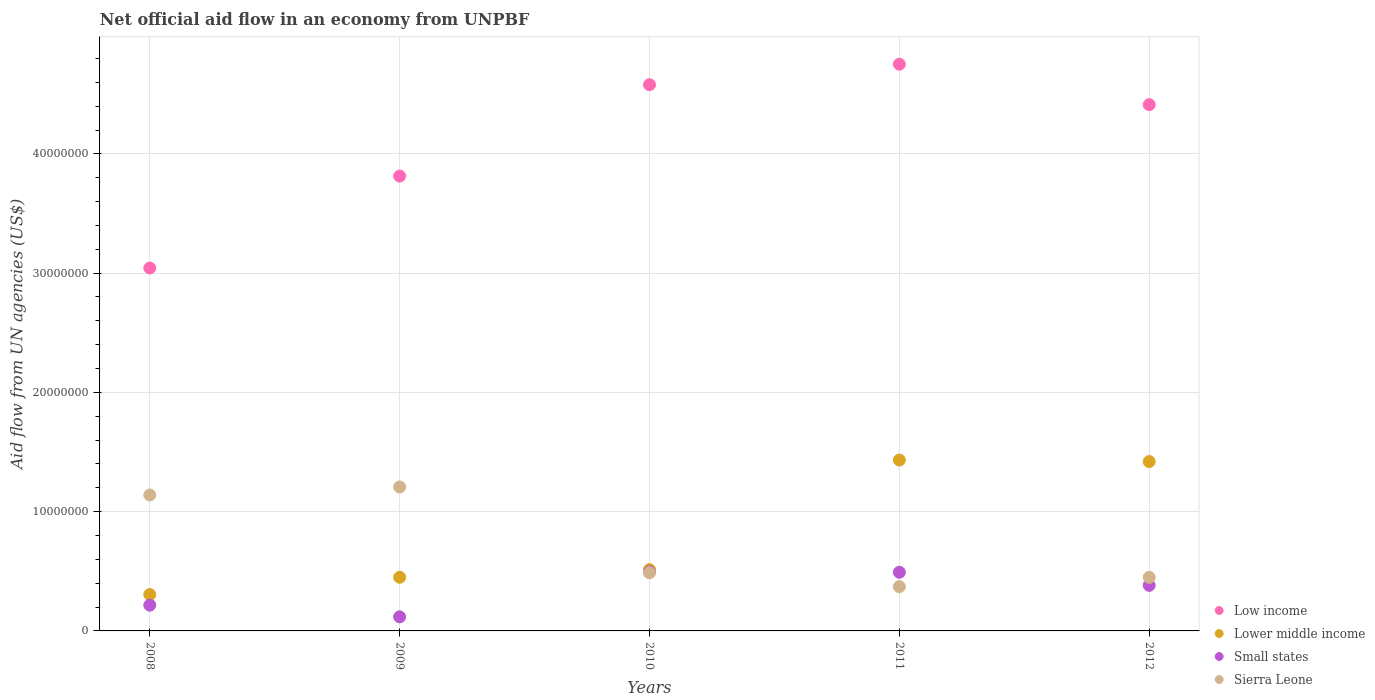How many different coloured dotlines are there?
Offer a terse response. 4. Is the number of dotlines equal to the number of legend labels?
Provide a short and direct response. Yes. What is the net official aid flow in Small states in 2010?
Provide a succinct answer. 4.95e+06. Across all years, what is the maximum net official aid flow in Lower middle income?
Keep it short and to the point. 1.43e+07. Across all years, what is the minimum net official aid flow in Low income?
Your answer should be compact. 3.04e+07. In which year was the net official aid flow in Low income minimum?
Provide a succinct answer. 2008. What is the total net official aid flow in Small states in the graph?
Your answer should be very brief. 1.70e+07. What is the difference between the net official aid flow in Lower middle income in 2010 and that in 2011?
Make the answer very short. -9.19e+06. What is the difference between the net official aid flow in Low income in 2009 and the net official aid flow in Sierra Leone in 2008?
Offer a terse response. 2.67e+07. What is the average net official aid flow in Small states per year?
Your answer should be compact. 3.41e+06. In the year 2009, what is the difference between the net official aid flow in Lower middle income and net official aid flow in Low income?
Your answer should be very brief. -3.36e+07. In how many years, is the net official aid flow in Lower middle income greater than 28000000 US$?
Ensure brevity in your answer.  0. What is the ratio of the net official aid flow in Lower middle income in 2009 to that in 2010?
Make the answer very short. 0.88. Is the difference between the net official aid flow in Lower middle income in 2008 and 2010 greater than the difference between the net official aid flow in Low income in 2008 and 2010?
Offer a very short reply. Yes. What is the difference between the highest and the second highest net official aid flow in Sierra Leone?
Make the answer very short. 6.70e+05. What is the difference between the highest and the lowest net official aid flow in Lower middle income?
Provide a short and direct response. 1.13e+07. In how many years, is the net official aid flow in Small states greater than the average net official aid flow in Small states taken over all years?
Ensure brevity in your answer.  3. Is the sum of the net official aid flow in Low income in 2008 and 2009 greater than the maximum net official aid flow in Small states across all years?
Make the answer very short. Yes. Is it the case that in every year, the sum of the net official aid flow in Small states and net official aid flow in Low income  is greater than the net official aid flow in Sierra Leone?
Give a very brief answer. Yes. What is the difference between two consecutive major ticks on the Y-axis?
Make the answer very short. 1.00e+07. Does the graph contain any zero values?
Make the answer very short. No. Does the graph contain grids?
Provide a short and direct response. Yes. How many legend labels are there?
Ensure brevity in your answer.  4. How are the legend labels stacked?
Offer a terse response. Vertical. What is the title of the graph?
Keep it short and to the point. Net official aid flow in an economy from UNPBF. What is the label or title of the X-axis?
Give a very brief answer. Years. What is the label or title of the Y-axis?
Your response must be concise. Aid flow from UN agencies (US$). What is the Aid flow from UN agencies (US$) of Low income in 2008?
Your answer should be very brief. 3.04e+07. What is the Aid flow from UN agencies (US$) of Lower middle income in 2008?
Provide a succinct answer. 3.05e+06. What is the Aid flow from UN agencies (US$) in Small states in 2008?
Keep it short and to the point. 2.16e+06. What is the Aid flow from UN agencies (US$) in Sierra Leone in 2008?
Keep it short and to the point. 1.14e+07. What is the Aid flow from UN agencies (US$) of Low income in 2009?
Give a very brief answer. 3.81e+07. What is the Aid flow from UN agencies (US$) in Lower middle income in 2009?
Provide a succinct answer. 4.50e+06. What is the Aid flow from UN agencies (US$) of Small states in 2009?
Your answer should be very brief. 1.18e+06. What is the Aid flow from UN agencies (US$) in Sierra Leone in 2009?
Offer a terse response. 1.21e+07. What is the Aid flow from UN agencies (US$) in Low income in 2010?
Your response must be concise. 4.58e+07. What is the Aid flow from UN agencies (US$) in Lower middle income in 2010?
Offer a terse response. 5.14e+06. What is the Aid flow from UN agencies (US$) of Small states in 2010?
Give a very brief answer. 4.95e+06. What is the Aid flow from UN agencies (US$) of Sierra Leone in 2010?
Give a very brief answer. 4.88e+06. What is the Aid flow from UN agencies (US$) of Low income in 2011?
Your answer should be compact. 4.75e+07. What is the Aid flow from UN agencies (US$) in Lower middle income in 2011?
Offer a terse response. 1.43e+07. What is the Aid flow from UN agencies (US$) in Small states in 2011?
Provide a succinct answer. 4.92e+06. What is the Aid flow from UN agencies (US$) of Sierra Leone in 2011?
Provide a succinct answer. 3.71e+06. What is the Aid flow from UN agencies (US$) in Low income in 2012?
Provide a short and direct response. 4.41e+07. What is the Aid flow from UN agencies (US$) of Lower middle income in 2012?
Provide a short and direct response. 1.42e+07. What is the Aid flow from UN agencies (US$) of Small states in 2012?
Keep it short and to the point. 3.82e+06. What is the Aid flow from UN agencies (US$) of Sierra Leone in 2012?
Give a very brief answer. 4.49e+06. Across all years, what is the maximum Aid flow from UN agencies (US$) of Low income?
Offer a terse response. 4.75e+07. Across all years, what is the maximum Aid flow from UN agencies (US$) of Lower middle income?
Make the answer very short. 1.43e+07. Across all years, what is the maximum Aid flow from UN agencies (US$) of Small states?
Offer a terse response. 4.95e+06. Across all years, what is the maximum Aid flow from UN agencies (US$) in Sierra Leone?
Give a very brief answer. 1.21e+07. Across all years, what is the minimum Aid flow from UN agencies (US$) in Low income?
Your answer should be very brief. 3.04e+07. Across all years, what is the minimum Aid flow from UN agencies (US$) of Lower middle income?
Offer a terse response. 3.05e+06. Across all years, what is the minimum Aid flow from UN agencies (US$) in Small states?
Offer a terse response. 1.18e+06. Across all years, what is the minimum Aid flow from UN agencies (US$) of Sierra Leone?
Your answer should be very brief. 3.71e+06. What is the total Aid flow from UN agencies (US$) in Low income in the graph?
Make the answer very short. 2.06e+08. What is the total Aid flow from UN agencies (US$) of Lower middle income in the graph?
Offer a very short reply. 4.12e+07. What is the total Aid flow from UN agencies (US$) in Small states in the graph?
Provide a succinct answer. 1.70e+07. What is the total Aid flow from UN agencies (US$) in Sierra Leone in the graph?
Your answer should be very brief. 3.66e+07. What is the difference between the Aid flow from UN agencies (US$) in Low income in 2008 and that in 2009?
Ensure brevity in your answer.  -7.71e+06. What is the difference between the Aid flow from UN agencies (US$) of Lower middle income in 2008 and that in 2009?
Ensure brevity in your answer.  -1.45e+06. What is the difference between the Aid flow from UN agencies (US$) of Small states in 2008 and that in 2009?
Keep it short and to the point. 9.80e+05. What is the difference between the Aid flow from UN agencies (US$) of Sierra Leone in 2008 and that in 2009?
Provide a succinct answer. -6.70e+05. What is the difference between the Aid flow from UN agencies (US$) in Low income in 2008 and that in 2010?
Offer a very short reply. -1.54e+07. What is the difference between the Aid flow from UN agencies (US$) in Lower middle income in 2008 and that in 2010?
Your answer should be very brief. -2.09e+06. What is the difference between the Aid flow from UN agencies (US$) of Small states in 2008 and that in 2010?
Offer a terse response. -2.79e+06. What is the difference between the Aid flow from UN agencies (US$) in Sierra Leone in 2008 and that in 2010?
Keep it short and to the point. 6.52e+06. What is the difference between the Aid flow from UN agencies (US$) in Low income in 2008 and that in 2011?
Give a very brief answer. -1.71e+07. What is the difference between the Aid flow from UN agencies (US$) of Lower middle income in 2008 and that in 2011?
Keep it short and to the point. -1.13e+07. What is the difference between the Aid flow from UN agencies (US$) of Small states in 2008 and that in 2011?
Offer a very short reply. -2.76e+06. What is the difference between the Aid flow from UN agencies (US$) of Sierra Leone in 2008 and that in 2011?
Ensure brevity in your answer.  7.69e+06. What is the difference between the Aid flow from UN agencies (US$) of Low income in 2008 and that in 2012?
Make the answer very short. -1.37e+07. What is the difference between the Aid flow from UN agencies (US$) of Lower middle income in 2008 and that in 2012?
Offer a very short reply. -1.12e+07. What is the difference between the Aid flow from UN agencies (US$) of Small states in 2008 and that in 2012?
Your response must be concise. -1.66e+06. What is the difference between the Aid flow from UN agencies (US$) of Sierra Leone in 2008 and that in 2012?
Offer a very short reply. 6.91e+06. What is the difference between the Aid flow from UN agencies (US$) in Low income in 2009 and that in 2010?
Offer a terse response. -7.66e+06. What is the difference between the Aid flow from UN agencies (US$) in Lower middle income in 2009 and that in 2010?
Provide a succinct answer. -6.40e+05. What is the difference between the Aid flow from UN agencies (US$) in Small states in 2009 and that in 2010?
Ensure brevity in your answer.  -3.77e+06. What is the difference between the Aid flow from UN agencies (US$) in Sierra Leone in 2009 and that in 2010?
Ensure brevity in your answer.  7.19e+06. What is the difference between the Aid flow from UN agencies (US$) in Low income in 2009 and that in 2011?
Offer a terse response. -9.38e+06. What is the difference between the Aid flow from UN agencies (US$) in Lower middle income in 2009 and that in 2011?
Give a very brief answer. -9.83e+06. What is the difference between the Aid flow from UN agencies (US$) of Small states in 2009 and that in 2011?
Offer a terse response. -3.74e+06. What is the difference between the Aid flow from UN agencies (US$) in Sierra Leone in 2009 and that in 2011?
Offer a terse response. 8.36e+06. What is the difference between the Aid flow from UN agencies (US$) in Low income in 2009 and that in 2012?
Provide a short and direct response. -5.99e+06. What is the difference between the Aid flow from UN agencies (US$) of Lower middle income in 2009 and that in 2012?
Your answer should be very brief. -9.70e+06. What is the difference between the Aid flow from UN agencies (US$) in Small states in 2009 and that in 2012?
Offer a terse response. -2.64e+06. What is the difference between the Aid flow from UN agencies (US$) of Sierra Leone in 2009 and that in 2012?
Provide a short and direct response. 7.58e+06. What is the difference between the Aid flow from UN agencies (US$) in Low income in 2010 and that in 2011?
Ensure brevity in your answer.  -1.72e+06. What is the difference between the Aid flow from UN agencies (US$) in Lower middle income in 2010 and that in 2011?
Provide a succinct answer. -9.19e+06. What is the difference between the Aid flow from UN agencies (US$) in Sierra Leone in 2010 and that in 2011?
Your answer should be compact. 1.17e+06. What is the difference between the Aid flow from UN agencies (US$) of Low income in 2010 and that in 2012?
Your answer should be compact. 1.67e+06. What is the difference between the Aid flow from UN agencies (US$) of Lower middle income in 2010 and that in 2012?
Keep it short and to the point. -9.06e+06. What is the difference between the Aid flow from UN agencies (US$) of Small states in 2010 and that in 2012?
Offer a terse response. 1.13e+06. What is the difference between the Aid flow from UN agencies (US$) in Sierra Leone in 2010 and that in 2012?
Give a very brief answer. 3.90e+05. What is the difference between the Aid flow from UN agencies (US$) in Low income in 2011 and that in 2012?
Provide a short and direct response. 3.39e+06. What is the difference between the Aid flow from UN agencies (US$) of Small states in 2011 and that in 2012?
Offer a terse response. 1.10e+06. What is the difference between the Aid flow from UN agencies (US$) of Sierra Leone in 2011 and that in 2012?
Provide a succinct answer. -7.80e+05. What is the difference between the Aid flow from UN agencies (US$) of Low income in 2008 and the Aid flow from UN agencies (US$) of Lower middle income in 2009?
Offer a terse response. 2.59e+07. What is the difference between the Aid flow from UN agencies (US$) of Low income in 2008 and the Aid flow from UN agencies (US$) of Small states in 2009?
Ensure brevity in your answer.  2.92e+07. What is the difference between the Aid flow from UN agencies (US$) of Low income in 2008 and the Aid flow from UN agencies (US$) of Sierra Leone in 2009?
Your answer should be compact. 1.84e+07. What is the difference between the Aid flow from UN agencies (US$) in Lower middle income in 2008 and the Aid flow from UN agencies (US$) in Small states in 2009?
Your answer should be very brief. 1.87e+06. What is the difference between the Aid flow from UN agencies (US$) in Lower middle income in 2008 and the Aid flow from UN agencies (US$) in Sierra Leone in 2009?
Your answer should be very brief. -9.02e+06. What is the difference between the Aid flow from UN agencies (US$) of Small states in 2008 and the Aid flow from UN agencies (US$) of Sierra Leone in 2009?
Your response must be concise. -9.91e+06. What is the difference between the Aid flow from UN agencies (US$) in Low income in 2008 and the Aid flow from UN agencies (US$) in Lower middle income in 2010?
Offer a terse response. 2.53e+07. What is the difference between the Aid flow from UN agencies (US$) in Low income in 2008 and the Aid flow from UN agencies (US$) in Small states in 2010?
Provide a succinct answer. 2.55e+07. What is the difference between the Aid flow from UN agencies (US$) in Low income in 2008 and the Aid flow from UN agencies (US$) in Sierra Leone in 2010?
Provide a succinct answer. 2.56e+07. What is the difference between the Aid flow from UN agencies (US$) of Lower middle income in 2008 and the Aid flow from UN agencies (US$) of Small states in 2010?
Provide a succinct answer. -1.90e+06. What is the difference between the Aid flow from UN agencies (US$) of Lower middle income in 2008 and the Aid flow from UN agencies (US$) of Sierra Leone in 2010?
Your answer should be compact. -1.83e+06. What is the difference between the Aid flow from UN agencies (US$) of Small states in 2008 and the Aid flow from UN agencies (US$) of Sierra Leone in 2010?
Your answer should be very brief. -2.72e+06. What is the difference between the Aid flow from UN agencies (US$) in Low income in 2008 and the Aid flow from UN agencies (US$) in Lower middle income in 2011?
Make the answer very short. 1.61e+07. What is the difference between the Aid flow from UN agencies (US$) in Low income in 2008 and the Aid flow from UN agencies (US$) in Small states in 2011?
Provide a succinct answer. 2.55e+07. What is the difference between the Aid flow from UN agencies (US$) of Low income in 2008 and the Aid flow from UN agencies (US$) of Sierra Leone in 2011?
Your answer should be compact. 2.67e+07. What is the difference between the Aid flow from UN agencies (US$) of Lower middle income in 2008 and the Aid flow from UN agencies (US$) of Small states in 2011?
Make the answer very short. -1.87e+06. What is the difference between the Aid flow from UN agencies (US$) of Lower middle income in 2008 and the Aid flow from UN agencies (US$) of Sierra Leone in 2011?
Make the answer very short. -6.60e+05. What is the difference between the Aid flow from UN agencies (US$) of Small states in 2008 and the Aid flow from UN agencies (US$) of Sierra Leone in 2011?
Your answer should be very brief. -1.55e+06. What is the difference between the Aid flow from UN agencies (US$) in Low income in 2008 and the Aid flow from UN agencies (US$) in Lower middle income in 2012?
Your answer should be compact. 1.62e+07. What is the difference between the Aid flow from UN agencies (US$) of Low income in 2008 and the Aid flow from UN agencies (US$) of Small states in 2012?
Offer a very short reply. 2.66e+07. What is the difference between the Aid flow from UN agencies (US$) in Low income in 2008 and the Aid flow from UN agencies (US$) in Sierra Leone in 2012?
Your answer should be very brief. 2.59e+07. What is the difference between the Aid flow from UN agencies (US$) of Lower middle income in 2008 and the Aid flow from UN agencies (US$) of Small states in 2012?
Provide a succinct answer. -7.70e+05. What is the difference between the Aid flow from UN agencies (US$) in Lower middle income in 2008 and the Aid flow from UN agencies (US$) in Sierra Leone in 2012?
Your response must be concise. -1.44e+06. What is the difference between the Aid flow from UN agencies (US$) in Small states in 2008 and the Aid flow from UN agencies (US$) in Sierra Leone in 2012?
Make the answer very short. -2.33e+06. What is the difference between the Aid flow from UN agencies (US$) of Low income in 2009 and the Aid flow from UN agencies (US$) of Lower middle income in 2010?
Provide a short and direct response. 3.30e+07. What is the difference between the Aid flow from UN agencies (US$) in Low income in 2009 and the Aid flow from UN agencies (US$) in Small states in 2010?
Make the answer very short. 3.32e+07. What is the difference between the Aid flow from UN agencies (US$) in Low income in 2009 and the Aid flow from UN agencies (US$) in Sierra Leone in 2010?
Your answer should be very brief. 3.33e+07. What is the difference between the Aid flow from UN agencies (US$) in Lower middle income in 2009 and the Aid flow from UN agencies (US$) in Small states in 2010?
Keep it short and to the point. -4.50e+05. What is the difference between the Aid flow from UN agencies (US$) in Lower middle income in 2009 and the Aid flow from UN agencies (US$) in Sierra Leone in 2010?
Ensure brevity in your answer.  -3.80e+05. What is the difference between the Aid flow from UN agencies (US$) in Small states in 2009 and the Aid flow from UN agencies (US$) in Sierra Leone in 2010?
Provide a succinct answer. -3.70e+06. What is the difference between the Aid flow from UN agencies (US$) of Low income in 2009 and the Aid flow from UN agencies (US$) of Lower middle income in 2011?
Make the answer very short. 2.38e+07. What is the difference between the Aid flow from UN agencies (US$) in Low income in 2009 and the Aid flow from UN agencies (US$) in Small states in 2011?
Your answer should be very brief. 3.32e+07. What is the difference between the Aid flow from UN agencies (US$) in Low income in 2009 and the Aid flow from UN agencies (US$) in Sierra Leone in 2011?
Give a very brief answer. 3.44e+07. What is the difference between the Aid flow from UN agencies (US$) of Lower middle income in 2009 and the Aid flow from UN agencies (US$) of Small states in 2011?
Your response must be concise. -4.20e+05. What is the difference between the Aid flow from UN agencies (US$) in Lower middle income in 2009 and the Aid flow from UN agencies (US$) in Sierra Leone in 2011?
Make the answer very short. 7.90e+05. What is the difference between the Aid flow from UN agencies (US$) in Small states in 2009 and the Aid flow from UN agencies (US$) in Sierra Leone in 2011?
Ensure brevity in your answer.  -2.53e+06. What is the difference between the Aid flow from UN agencies (US$) in Low income in 2009 and the Aid flow from UN agencies (US$) in Lower middle income in 2012?
Your answer should be compact. 2.39e+07. What is the difference between the Aid flow from UN agencies (US$) in Low income in 2009 and the Aid flow from UN agencies (US$) in Small states in 2012?
Keep it short and to the point. 3.43e+07. What is the difference between the Aid flow from UN agencies (US$) of Low income in 2009 and the Aid flow from UN agencies (US$) of Sierra Leone in 2012?
Provide a succinct answer. 3.36e+07. What is the difference between the Aid flow from UN agencies (US$) of Lower middle income in 2009 and the Aid flow from UN agencies (US$) of Small states in 2012?
Provide a succinct answer. 6.80e+05. What is the difference between the Aid flow from UN agencies (US$) of Small states in 2009 and the Aid flow from UN agencies (US$) of Sierra Leone in 2012?
Your answer should be compact. -3.31e+06. What is the difference between the Aid flow from UN agencies (US$) in Low income in 2010 and the Aid flow from UN agencies (US$) in Lower middle income in 2011?
Keep it short and to the point. 3.15e+07. What is the difference between the Aid flow from UN agencies (US$) of Low income in 2010 and the Aid flow from UN agencies (US$) of Small states in 2011?
Your answer should be compact. 4.09e+07. What is the difference between the Aid flow from UN agencies (US$) of Low income in 2010 and the Aid flow from UN agencies (US$) of Sierra Leone in 2011?
Your answer should be compact. 4.21e+07. What is the difference between the Aid flow from UN agencies (US$) in Lower middle income in 2010 and the Aid flow from UN agencies (US$) in Small states in 2011?
Offer a very short reply. 2.20e+05. What is the difference between the Aid flow from UN agencies (US$) in Lower middle income in 2010 and the Aid flow from UN agencies (US$) in Sierra Leone in 2011?
Ensure brevity in your answer.  1.43e+06. What is the difference between the Aid flow from UN agencies (US$) in Small states in 2010 and the Aid flow from UN agencies (US$) in Sierra Leone in 2011?
Ensure brevity in your answer.  1.24e+06. What is the difference between the Aid flow from UN agencies (US$) in Low income in 2010 and the Aid flow from UN agencies (US$) in Lower middle income in 2012?
Offer a very short reply. 3.16e+07. What is the difference between the Aid flow from UN agencies (US$) in Low income in 2010 and the Aid flow from UN agencies (US$) in Small states in 2012?
Your response must be concise. 4.20e+07. What is the difference between the Aid flow from UN agencies (US$) in Low income in 2010 and the Aid flow from UN agencies (US$) in Sierra Leone in 2012?
Give a very brief answer. 4.13e+07. What is the difference between the Aid flow from UN agencies (US$) of Lower middle income in 2010 and the Aid flow from UN agencies (US$) of Small states in 2012?
Ensure brevity in your answer.  1.32e+06. What is the difference between the Aid flow from UN agencies (US$) of Lower middle income in 2010 and the Aid flow from UN agencies (US$) of Sierra Leone in 2012?
Provide a succinct answer. 6.50e+05. What is the difference between the Aid flow from UN agencies (US$) in Small states in 2010 and the Aid flow from UN agencies (US$) in Sierra Leone in 2012?
Provide a succinct answer. 4.60e+05. What is the difference between the Aid flow from UN agencies (US$) in Low income in 2011 and the Aid flow from UN agencies (US$) in Lower middle income in 2012?
Keep it short and to the point. 3.33e+07. What is the difference between the Aid flow from UN agencies (US$) in Low income in 2011 and the Aid flow from UN agencies (US$) in Small states in 2012?
Your answer should be compact. 4.37e+07. What is the difference between the Aid flow from UN agencies (US$) of Low income in 2011 and the Aid flow from UN agencies (US$) of Sierra Leone in 2012?
Your answer should be compact. 4.30e+07. What is the difference between the Aid flow from UN agencies (US$) in Lower middle income in 2011 and the Aid flow from UN agencies (US$) in Small states in 2012?
Ensure brevity in your answer.  1.05e+07. What is the difference between the Aid flow from UN agencies (US$) of Lower middle income in 2011 and the Aid flow from UN agencies (US$) of Sierra Leone in 2012?
Keep it short and to the point. 9.84e+06. What is the difference between the Aid flow from UN agencies (US$) of Small states in 2011 and the Aid flow from UN agencies (US$) of Sierra Leone in 2012?
Keep it short and to the point. 4.30e+05. What is the average Aid flow from UN agencies (US$) of Low income per year?
Your answer should be compact. 4.12e+07. What is the average Aid flow from UN agencies (US$) in Lower middle income per year?
Your answer should be compact. 8.24e+06. What is the average Aid flow from UN agencies (US$) of Small states per year?
Keep it short and to the point. 3.41e+06. What is the average Aid flow from UN agencies (US$) in Sierra Leone per year?
Ensure brevity in your answer.  7.31e+06. In the year 2008, what is the difference between the Aid flow from UN agencies (US$) of Low income and Aid flow from UN agencies (US$) of Lower middle income?
Provide a short and direct response. 2.74e+07. In the year 2008, what is the difference between the Aid flow from UN agencies (US$) in Low income and Aid flow from UN agencies (US$) in Small states?
Your answer should be very brief. 2.83e+07. In the year 2008, what is the difference between the Aid flow from UN agencies (US$) in Low income and Aid flow from UN agencies (US$) in Sierra Leone?
Your answer should be compact. 1.90e+07. In the year 2008, what is the difference between the Aid flow from UN agencies (US$) of Lower middle income and Aid flow from UN agencies (US$) of Small states?
Your answer should be compact. 8.90e+05. In the year 2008, what is the difference between the Aid flow from UN agencies (US$) of Lower middle income and Aid flow from UN agencies (US$) of Sierra Leone?
Provide a succinct answer. -8.35e+06. In the year 2008, what is the difference between the Aid flow from UN agencies (US$) in Small states and Aid flow from UN agencies (US$) in Sierra Leone?
Give a very brief answer. -9.24e+06. In the year 2009, what is the difference between the Aid flow from UN agencies (US$) in Low income and Aid flow from UN agencies (US$) in Lower middle income?
Your answer should be compact. 3.36e+07. In the year 2009, what is the difference between the Aid flow from UN agencies (US$) in Low income and Aid flow from UN agencies (US$) in Small states?
Offer a terse response. 3.70e+07. In the year 2009, what is the difference between the Aid flow from UN agencies (US$) of Low income and Aid flow from UN agencies (US$) of Sierra Leone?
Provide a succinct answer. 2.61e+07. In the year 2009, what is the difference between the Aid flow from UN agencies (US$) of Lower middle income and Aid flow from UN agencies (US$) of Small states?
Provide a short and direct response. 3.32e+06. In the year 2009, what is the difference between the Aid flow from UN agencies (US$) in Lower middle income and Aid flow from UN agencies (US$) in Sierra Leone?
Provide a succinct answer. -7.57e+06. In the year 2009, what is the difference between the Aid flow from UN agencies (US$) of Small states and Aid flow from UN agencies (US$) of Sierra Leone?
Ensure brevity in your answer.  -1.09e+07. In the year 2010, what is the difference between the Aid flow from UN agencies (US$) of Low income and Aid flow from UN agencies (US$) of Lower middle income?
Give a very brief answer. 4.07e+07. In the year 2010, what is the difference between the Aid flow from UN agencies (US$) of Low income and Aid flow from UN agencies (US$) of Small states?
Provide a succinct answer. 4.08e+07. In the year 2010, what is the difference between the Aid flow from UN agencies (US$) of Low income and Aid flow from UN agencies (US$) of Sierra Leone?
Offer a very short reply. 4.09e+07. In the year 2010, what is the difference between the Aid flow from UN agencies (US$) of Lower middle income and Aid flow from UN agencies (US$) of Sierra Leone?
Ensure brevity in your answer.  2.60e+05. In the year 2011, what is the difference between the Aid flow from UN agencies (US$) of Low income and Aid flow from UN agencies (US$) of Lower middle income?
Keep it short and to the point. 3.32e+07. In the year 2011, what is the difference between the Aid flow from UN agencies (US$) of Low income and Aid flow from UN agencies (US$) of Small states?
Offer a very short reply. 4.26e+07. In the year 2011, what is the difference between the Aid flow from UN agencies (US$) in Low income and Aid flow from UN agencies (US$) in Sierra Leone?
Offer a very short reply. 4.38e+07. In the year 2011, what is the difference between the Aid flow from UN agencies (US$) in Lower middle income and Aid flow from UN agencies (US$) in Small states?
Ensure brevity in your answer.  9.41e+06. In the year 2011, what is the difference between the Aid flow from UN agencies (US$) in Lower middle income and Aid flow from UN agencies (US$) in Sierra Leone?
Your response must be concise. 1.06e+07. In the year 2011, what is the difference between the Aid flow from UN agencies (US$) in Small states and Aid flow from UN agencies (US$) in Sierra Leone?
Give a very brief answer. 1.21e+06. In the year 2012, what is the difference between the Aid flow from UN agencies (US$) in Low income and Aid flow from UN agencies (US$) in Lower middle income?
Your answer should be very brief. 2.99e+07. In the year 2012, what is the difference between the Aid flow from UN agencies (US$) of Low income and Aid flow from UN agencies (US$) of Small states?
Make the answer very short. 4.03e+07. In the year 2012, what is the difference between the Aid flow from UN agencies (US$) in Low income and Aid flow from UN agencies (US$) in Sierra Leone?
Offer a terse response. 3.96e+07. In the year 2012, what is the difference between the Aid flow from UN agencies (US$) of Lower middle income and Aid flow from UN agencies (US$) of Small states?
Make the answer very short. 1.04e+07. In the year 2012, what is the difference between the Aid flow from UN agencies (US$) in Lower middle income and Aid flow from UN agencies (US$) in Sierra Leone?
Keep it short and to the point. 9.71e+06. In the year 2012, what is the difference between the Aid flow from UN agencies (US$) of Small states and Aid flow from UN agencies (US$) of Sierra Leone?
Your answer should be very brief. -6.70e+05. What is the ratio of the Aid flow from UN agencies (US$) in Low income in 2008 to that in 2009?
Your answer should be very brief. 0.8. What is the ratio of the Aid flow from UN agencies (US$) in Lower middle income in 2008 to that in 2009?
Your response must be concise. 0.68. What is the ratio of the Aid flow from UN agencies (US$) of Small states in 2008 to that in 2009?
Your response must be concise. 1.83. What is the ratio of the Aid flow from UN agencies (US$) in Sierra Leone in 2008 to that in 2009?
Offer a very short reply. 0.94. What is the ratio of the Aid flow from UN agencies (US$) in Low income in 2008 to that in 2010?
Give a very brief answer. 0.66. What is the ratio of the Aid flow from UN agencies (US$) in Lower middle income in 2008 to that in 2010?
Keep it short and to the point. 0.59. What is the ratio of the Aid flow from UN agencies (US$) of Small states in 2008 to that in 2010?
Your response must be concise. 0.44. What is the ratio of the Aid flow from UN agencies (US$) of Sierra Leone in 2008 to that in 2010?
Provide a succinct answer. 2.34. What is the ratio of the Aid flow from UN agencies (US$) of Low income in 2008 to that in 2011?
Make the answer very short. 0.64. What is the ratio of the Aid flow from UN agencies (US$) of Lower middle income in 2008 to that in 2011?
Keep it short and to the point. 0.21. What is the ratio of the Aid flow from UN agencies (US$) of Small states in 2008 to that in 2011?
Keep it short and to the point. 0.44. What is the ratio of the Aid flow from UN agencies (US$) in Sierra Leone in 2008 to that in 2011?
Keep it short and to the point. 3.07. What is the ratio of the Aid flow from UN agencies (US$) of Low income in 2008 to that in 2012?
Make the answer very short. 0.69. What is the ratio of the Aid flow from UN agencies (US$) in Lower middle income in 2008 to that in 2012?
Provide a short and direct response. 0.21. What is the ratio of the Aid flow from UN agencies (US$) of Small states in 2008 to that in 2012?
Your response must be concise. 0.57. What is the ratio of the Aid flow from UN agencies (US$) of Sierra Leone in 2008 to that in 2012?
Give a very brief answer. 2.54. What is the ratio of the Aid flow from UN agencies (US$) of Low income in 2009 to that in 2010?
Keep it short and to the point. 0.83. What is the ratio of the Aid flow from UN agencies (US$) of Lower middle income in 2009 to that in 2010?
Your answer should be compact. 0.88. What is the ratio of the Aid flow from UN agencies (US$) of Small states in 2009 to that in 2010?
Provide a succinct answer. 0.24. What is the ratio of the Aid flow from UN agencies (US$) of Sierra Leone in 2009 to that in 2010?
Provide a short and direct response. 2.47. What is the ratio of the Aid flow from UN agencies (US$) in Low income in 2009 to that in 2011?
Your answer should be very brief. 0.8. What is the ratio of the Aid flow from UN agencies (US$) in Lower middle income in 2009 to that in 2011?
Provide a succinct answer. 0.31. What is the ratio of the Aid flow from UN agencies (US$) of Small states in 2009 to that in 2011?
Give a very brief answer. 0.24. What is the ratio of the Aid flow from UN agencies (US$) of Sierra Leone in 2009 to that in 2011?
Your answer should be compact. 3.25. What is the ratio of the Aid flow from UN agencies (US$) of Low income in 2009 to that in 2012?
Keep it short and to the point. 0.86. What is the ratio of the Aid flow from UN agencies (US$) in Lower middle income in 2009 to that in 2012?
Provide a succinct answer. 0.32. What is the ratio of the Aid flow from UN agencies (US$) of Small states in 2009 to that in 2012?
Give a very brief answer. 0.31. What is the ratio of the Aid flow from UN agencies (US$) in Sierra Leone in 2009 to that in 2012?
Provide a succinct answer. 2.69. What is the ratio of the Aid flow from UN agencies (US$) of Low income in 2010 to that in 2011?
Give a very brief answer. 0.96. What is the ratio of the Aid flow from UN agencies (US$) in Lower middle income in 2010 to that in 2011?
Offer a terse response. 0.36. What is the ratio of the Aid flow from UN agencies (US$) in Sierra Leone in 2010 to that in 2011?
Offer a terse response. 1.32. What is the ratio of the Aid flow from UN agencies (US$) in Low income in 2010 to that in 2012?
Provide a short and direct response. 1.04. What is the ratio of the Aid flow from UN agencies (US$) in Lower middle income in 2010 to that in 2012?
Provide a succinct answer. 0.36. What is the ratio of the Aid flow from UN agencies (US$) of Small states in 2010 to that in 2012?
Provide a succinct answer. 1.3. What is the ratio of the Aid flow from UN agencies (US$) of Sierra Leone in 2010 to that in 2012?
Your answer should be compact. 1.09. What is the ratio of the Aid flow from UN agencies (US$) of Low income in 2011 to that in 2012?
Your answer should be compact. 1.08. What is the ratio of the Aid flow from UN agencies (US$) of Lower middle income in 2011 to that in 2012?
Your answer should be very brief. 1.01. What is the ratio of the Aid flow from UN agencies (US$) in Small states in 2011 to that in 2012?
Give a very brief answer. 1.29. What is the ratio of the Aid flow from UN agencies (US$) in Sierra Leone in 2011 to that in 2012?
Offer a very short reply. 0.83. What is the difference between the highest and the second highest Aid flow from UN agencies (US$) of Low income?
Provide a short and direct response. 1.72e+06. What is the difference between the highest and the second highest Aid flow from UN agencies (US$) in Lower middle income?
Offer a very short reply. 1.30e+05. What is the difference between the highest and the second highest Aid flow from UN agencies (US$) in Sierra Leone?
Offer a terse response. 6.70e+05. What is the difference between the highest and the lowest Aid flow from UN agencies (US$) of Low income?
Ensure brevity in your answer.  1.71e+07. What is the difference between the highest and the lowest Aid flow from UN agencies (US$) in Lower middle income?
Give a very brief answer. 1.13e+07. What is the difference between the highest and the lowest Aid flow from UN agencies (US$) in Small states?
Your response must be concise. 3.77e+06. What is the difference between the highest and the lowest Aid flow from UN agencies (US$) of Sierra Leone?
Offer a very short reply. 8.36e+06. 